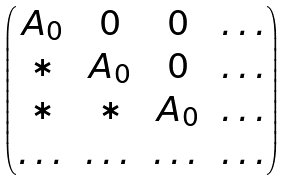Convert formula to latex. <formula><loc_0><loc_0><loc_500><loc_500>\begin{pmatrix} A _ { 0 } & 0 & 0 & \dots \\ * & A _ { 0 } & 0 & \dots \\ * & * & A _ { 0 } & \dots \\ \dots & \dots & \dots & \dots \end{pmatrix}</formula> 